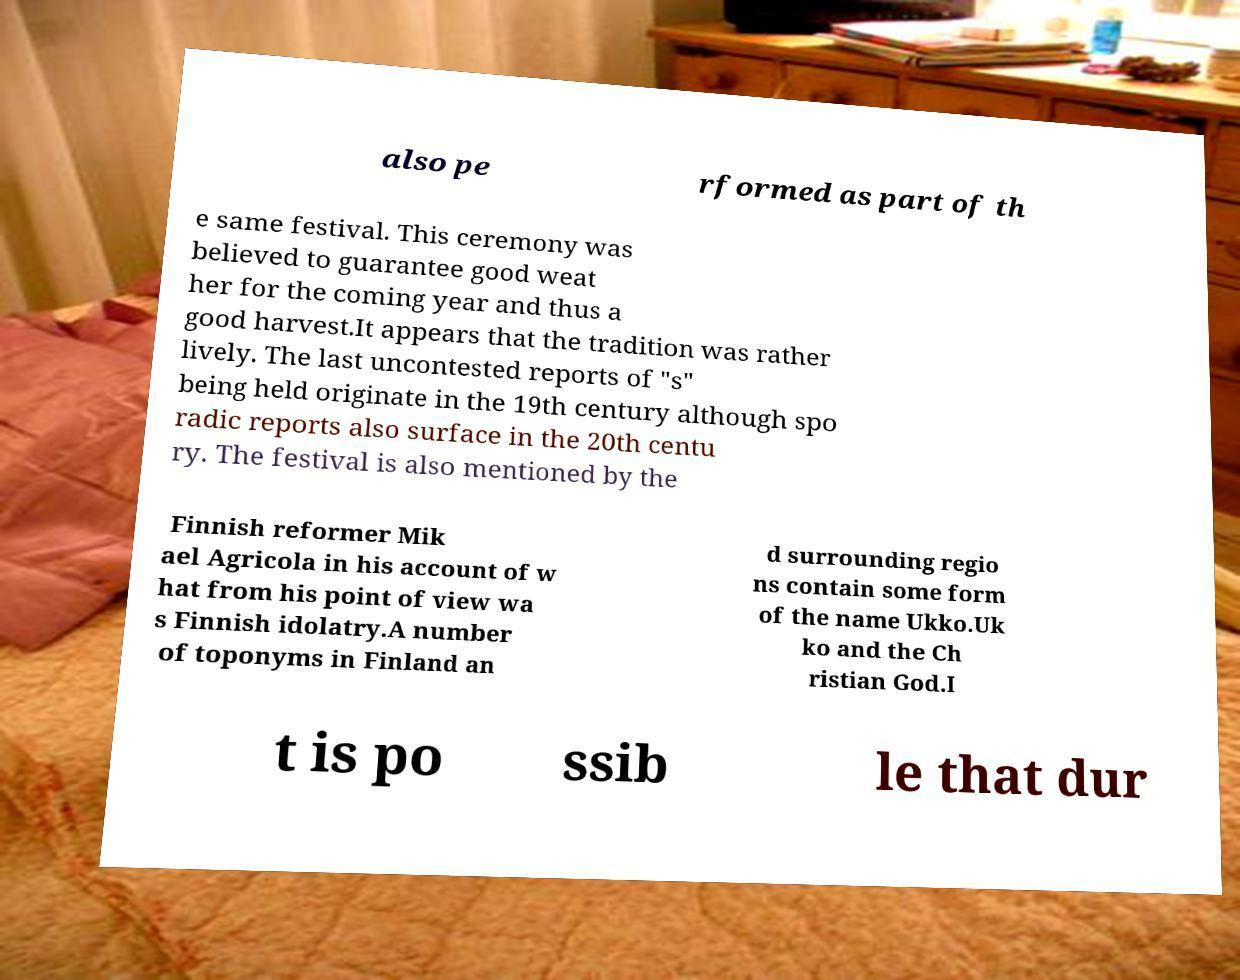Could you extract and type out the text from this image? also pe rformed as part of th e same festival. This ceremony was believed to guarantee good weat her for the coming year and thus a good harvest.It appears that the tradition was rather lively. The last uncontested reports of "s" being held originate in the 19th century although spo radic reports also surface in the 20th centu ry. The festival is also mentioned by the Finnish reformer Mik ael Agricola in his account of w hat from his point of view wa s Finnish idolatry.A number of toponyms in Finland an d surrounding regio ns contain some form of the name Ukko.Uk ko and the Ch ristian God.I t is po ssib le that dur 